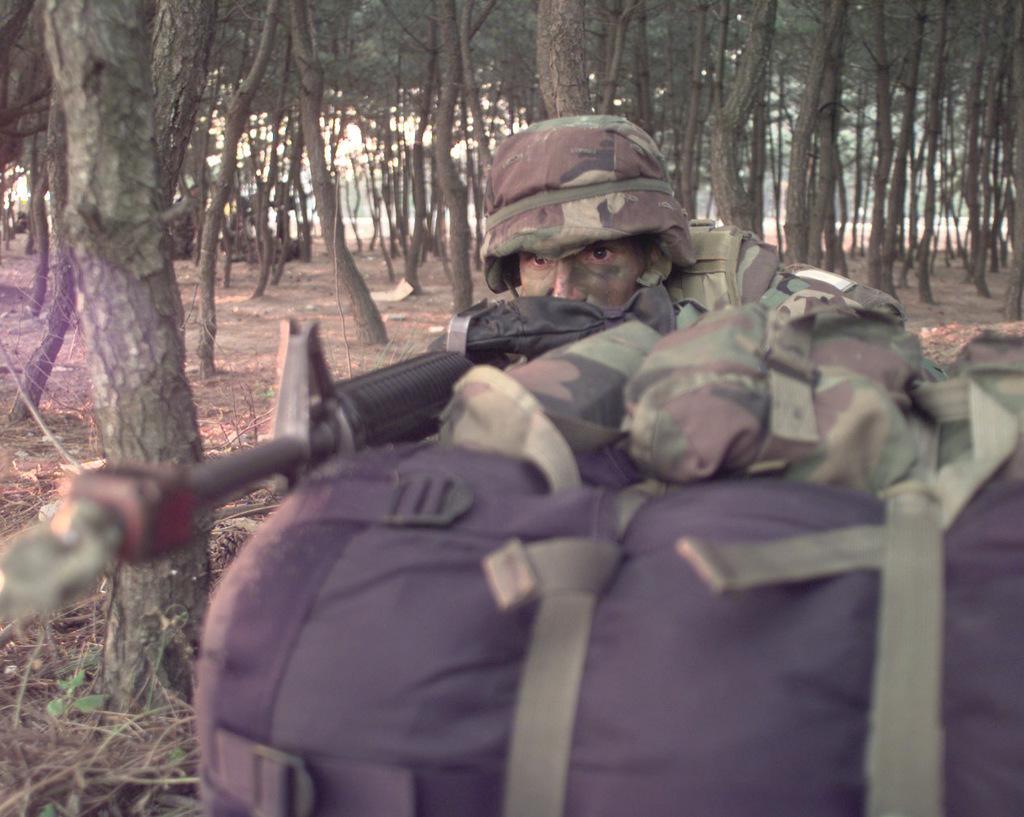Could you give a brief overview of what you see in this image? In this image we can see some trees on the ground, few objects on the ground, it looks like a road in the background, few leaves, some dried stems on the ground, one bag on the ground, it looks like sunlight in the sky, one military man wearing a cap and holding a gun. 